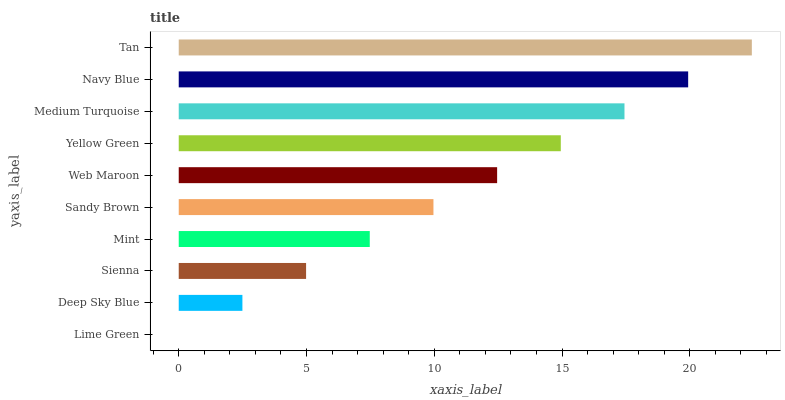Is Lime Green the minimum?
Answer yes or no. Yes. Is Tan the maximum?
Answer yes or no. Yes. Is Deep Sky Blue the minimum?
Answer yes or no. No. Is Deep Sky Blue the maximum?
Answer yes or no. No. Is Deep Sky Blue greater than Lime Green?
Answer yes or no. Yes. Is Lime Green less than Deep Sky Blue?
Answer yes or no. Yes. Is Lime Green greater than Deep Sky Blue?
Answer yes or no. No. Is Deep Sky Blue less than Lime Green?
Answer yes or no. No. Is Web Maroon the high median?
Answer yes or no. Yes. Is Sandy Brown the low median?
Answer yes or no. Yes. Is Yellow Green the high median?
Answer yes or no. No. Is Medium Turquoise the low median?
Answer yes or no. No. 